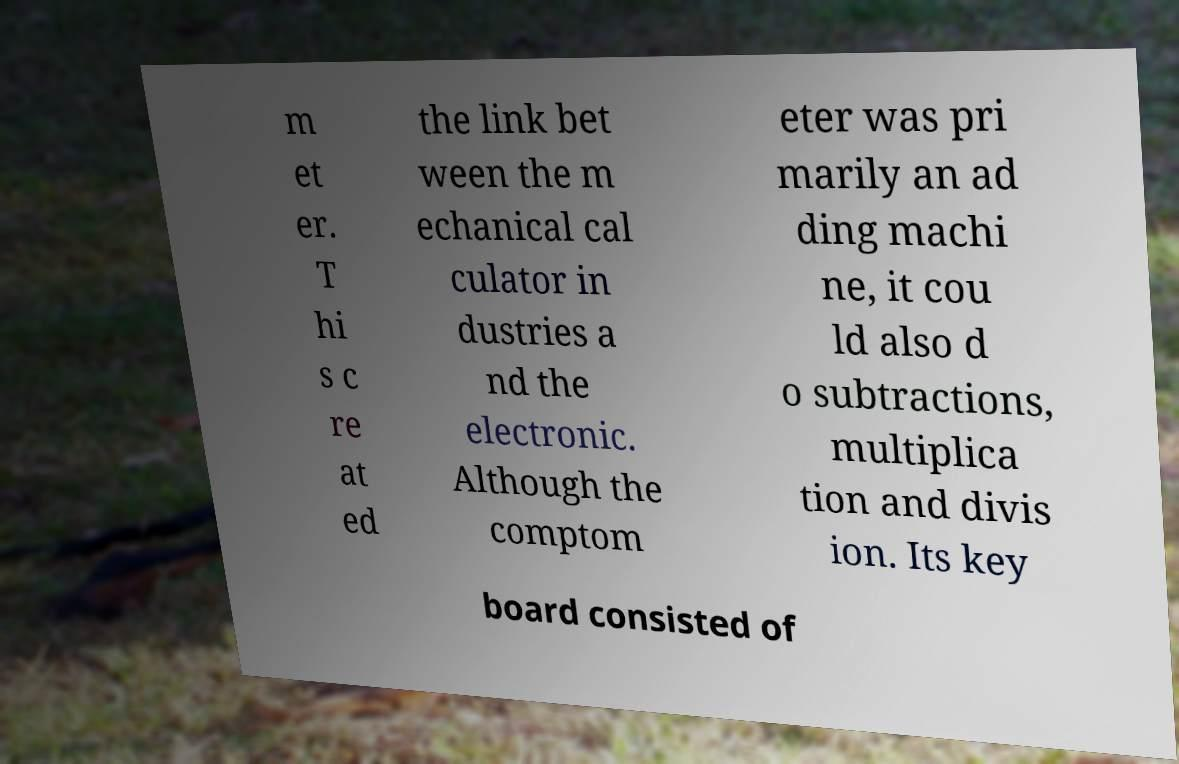Could you extract and type out the text from this image? m et er. T hi s c re at ed the link bet ween the m echanical cal culator in dustries a nd the electronic. Although the comptom eter was pri marily an ad ding machi ne, it cou ld also d o subtractions, multiplica tion and divis ion. Its key board consisted of 